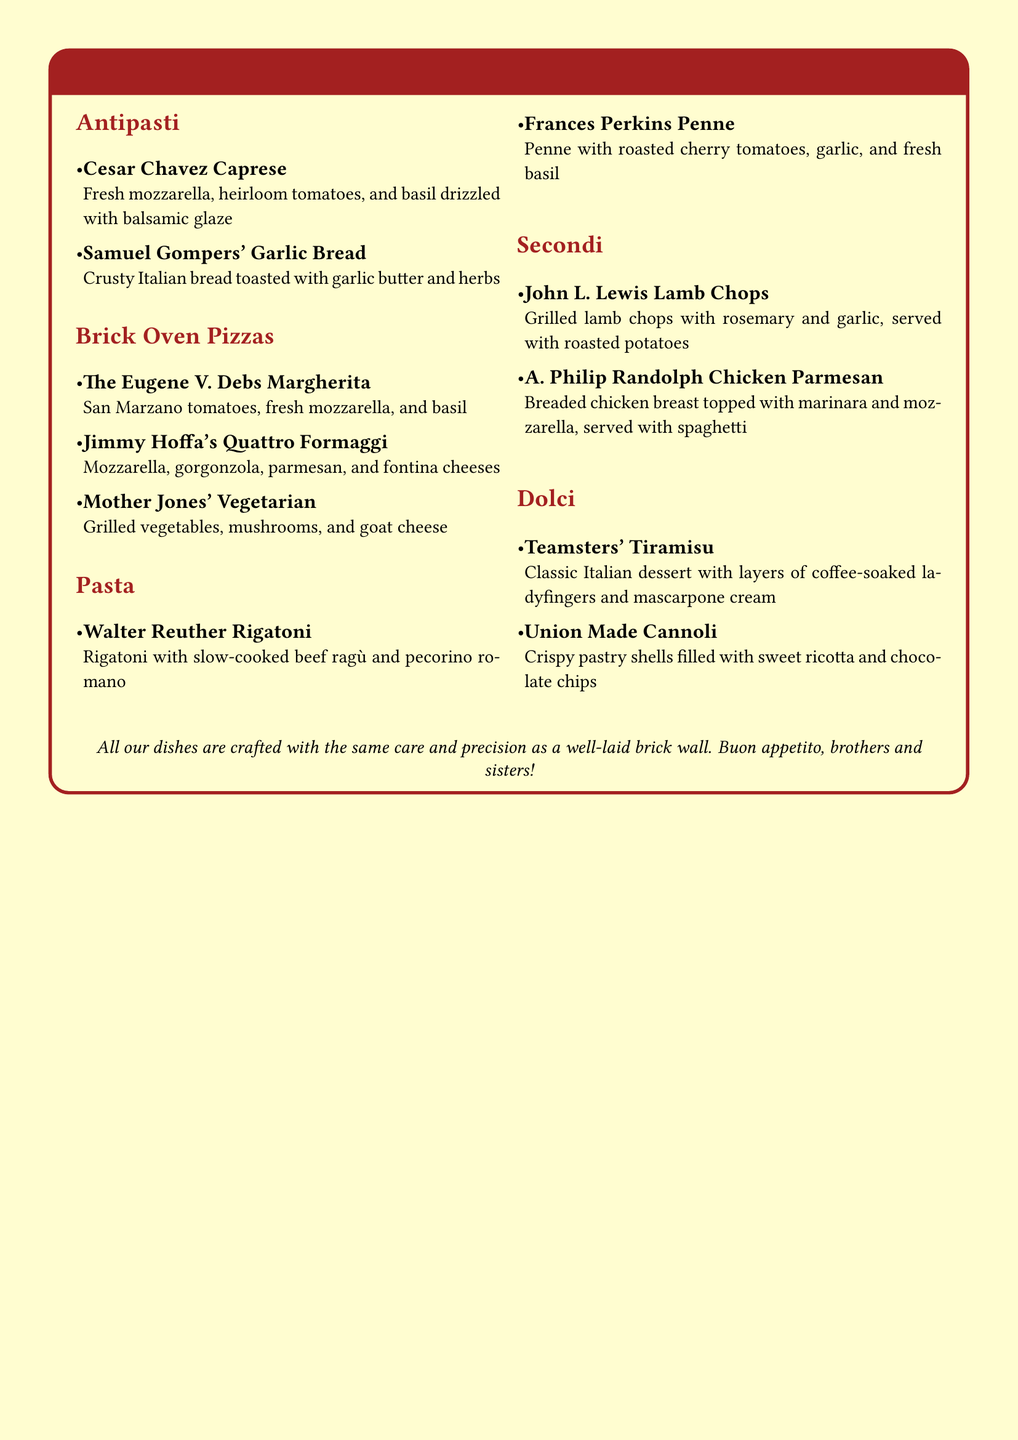What is the name of the first antipasto dish? The first dish listed under antipasti is "Cesar Chavez Caprese."
Answer: Cesar Chavez Caprese How many brick oven pizzas are on the menu? There are three pizzas listed under the brick oven pizzas section.
Answer: 3 What cheese is used in Jimmy Hoffa's pizza? The pizza "Jimmy Hoffa's Quattro Formaggi" includes mozzarella, gorgonzola, parmesan, and fontina cheeses.
Answer: mozzarella, gorgonzola, parmesan, fontina Which dish is named after a famous labor leader associated with lamb? The dish is "John L. Lewis Lamb Chops."
Answer: John L. Lewis Lamb Chops What dessert features coffee-soaked ladyfingers? The dessert "Teamsters' Tiramisu" features coffee-soaked ladyfingers.
Answer: Teamsters' Tiramisu What type of pasta is used in the Walter Reuther dish? The pasta used in the Walter Reuther dish is rigatoni.
Answer: Rigatoni Which dish is vegetarian on the menu? The vegetarian dish is "Mother Jones' Vegetarian."
Answer: Mother Jones' Vegetarian What is included in the Union Made Cannoli? The Union Made Cannoli is filled with sweet ricotta and chocolate chips.
Answer: sweet ricotta and chocolate chips 